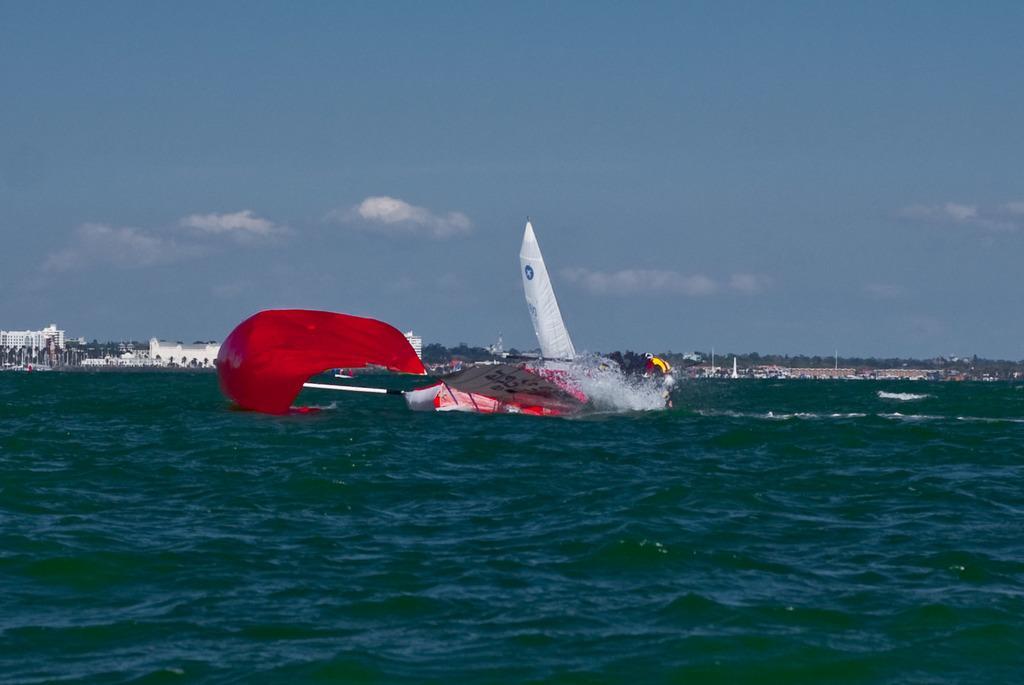In one or two sentences, can you explain what this image depicts? In this image we can see the water. On the water we can see an object looks like paragliding equipment. In the background, we can see a group of buildings and trees. At the top we can see the sky. 